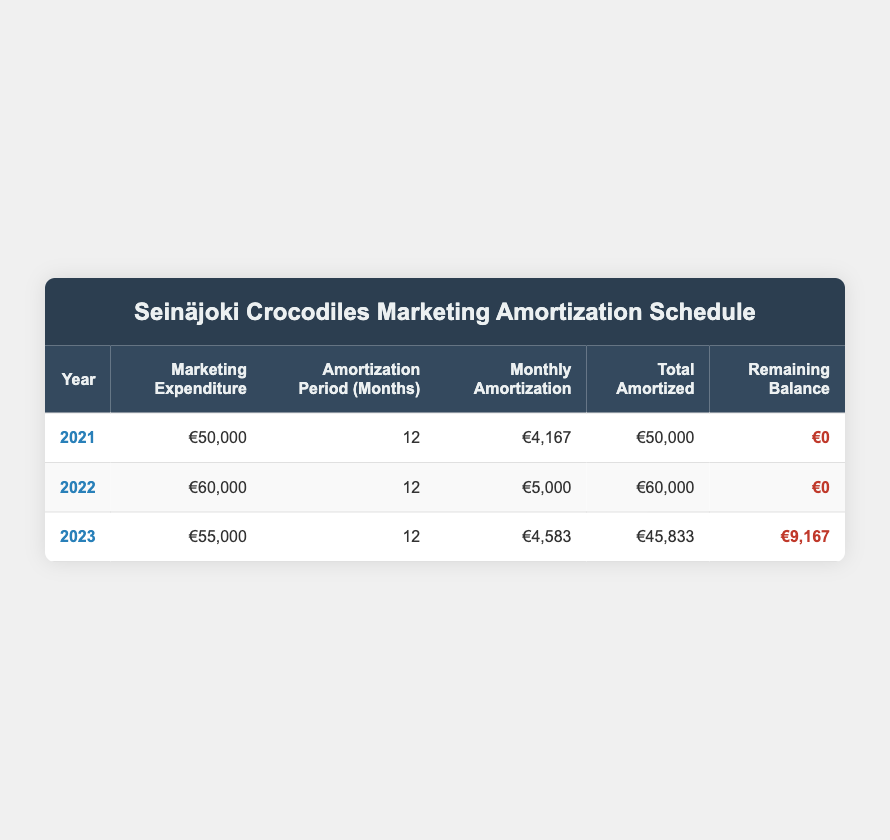What was the total marketing expenditure in 2021? The table shows that the marketing expenditure for the year 2021 is €50,000. Therefore, referencing the table directly gives the answer.
Answer: €50,000 What was the monthly amortization amount for 2022? According to the table, the monthly amortization for the year 2022 is €5,000. This can be identified directly from the respective row for 2022.
Answer: €5,000 Did the Seinäjoki Crocodiles have any remaining balance for marketing expenditures at the end of 2021? The table indicates that the remaining balance for 2021 is €0. This means there was no outstanding amount at the end of that year.
Answer: No How much was the total amortized amount for 2023 compared to the marketing expenditure for that year? For 2023, the total amortized amount is €45,833, while the marketing expenditure is €55,000. By comparing these two values, it's evident that the total amortized amount is less than the marketing expenditure for that year, indicating a remaining balance.
Answer: €45,833 What is the difference in marketing expenditures between the years 2021 and 2022? The marketing expenditure for 2021 is €50,000 and for 2022 is €60,000. To find the difference, we subtract the 2021 amount from the 2022 amount: €60,000 - €50,000 = €10,000. This shows that the marketing expenditure increased by €10,000 from 2021 to 2022.
Answer: €10,000 Was the total amortized amount in 2023 higher, lower, or equal to that of 2022? In 2022, the total amortized amount was €60,000, whereas in 2023 it was €45,833. Since €45,833 is less than €60,000, the answer is that the total amortized amount in 2023 was lower.
Answer: Lower What is the average monthly amortization for all three years? To find the average monthly amortization, we first sum the monthly amortizations for all three years: €4,167 (2021) + €5,000 (2022) + €4,583 (2023) = €13,750. Then, we divide this by 3 (the number of years): €13,750 / 3 = €4,583.33. Thus, the average monthly amortization over the three years is €4,583.33.
Answer: €4,583.33 How much total marketing expenditure is amortized over the three years? The total marketing expenditure amortized over the three years is the sum of the total amortized amounts for each year: €50,000 (2021) + €60,000 (2022) + €45,833 (2023) = €155,833. This indicates the combined total that has been amortized from marketing expenditures.
Answer: €155,833 Was the monthly amortization in 2023 greater than in 2021? The monthly amortization for 2021 is €4,167, while for 2023 it is €4,583. Since €4,583 is greater than €4,167, we can conclude that the monthly amortization in 2023 was indeed greater.
Answer: Yes 